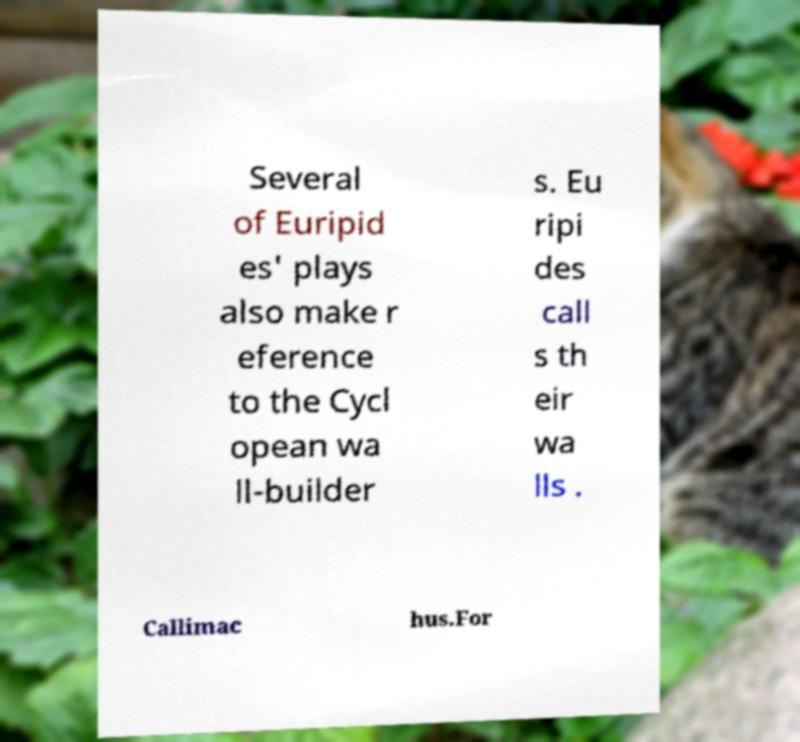Could you assist in decoding the text presented in this image and type it out clearly? Several of Euripid es' plays also make r eference to the Cycl opean wa ll-builder s. Eu ripi des call s th eir wa lls . Callimac hus.For 